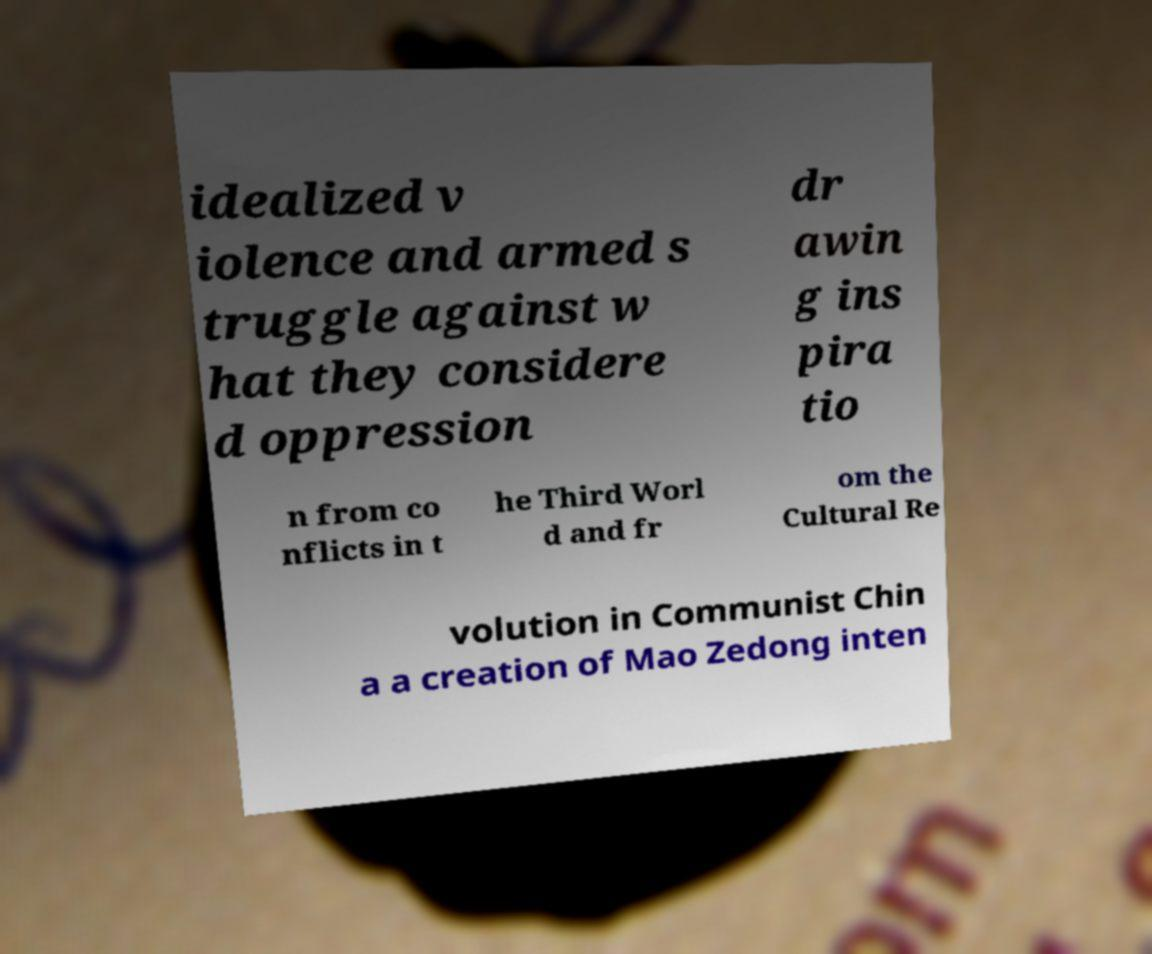Can you read and provide the text displayed in the image?This photo seems to have some interesting text. Can you extract and type it out for me? idealized v iolence and armed s truggle against w hat they considere d oppression dr awin g ins pira tio n from co nflicts in t he Third Worl d and fr om the Cultural Re volution in Communist Chin a a creation of Mao Zedong inten 